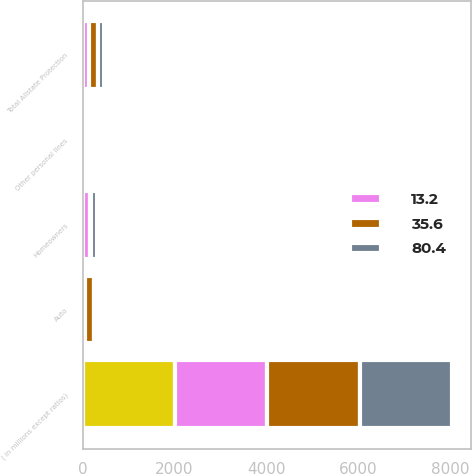<chart> <loc_0><loc_0><loc_500><loc_500><stacked_bar_chart><ecel><fcel>( in millions except ratios)<fcel>Auto<fcel>Homeowners<fcel>Other personal lines<fcel>Total Allstate Protection<nl><fcel>35.6<fcel>2010<fcel>179<fcel>23<fcel>15<fcel>187<nl><fcel>nan<fcel>2010<fcel>0.7<fcel>0.1<fcel>0.1<fcel>0.7<nl><fcel>13.2<fcel>2009<fcel>57<fcel>168<fcel>89<fcel>136<nl><fcel>80.4<fcel>2008<fcel>27<fcel>124<fcel>55<fcel>152<nl></chart> 